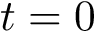Convert formula to latex. <formula><loc_0><loc_0><loc_500><loc_500>t = 0</formula> 